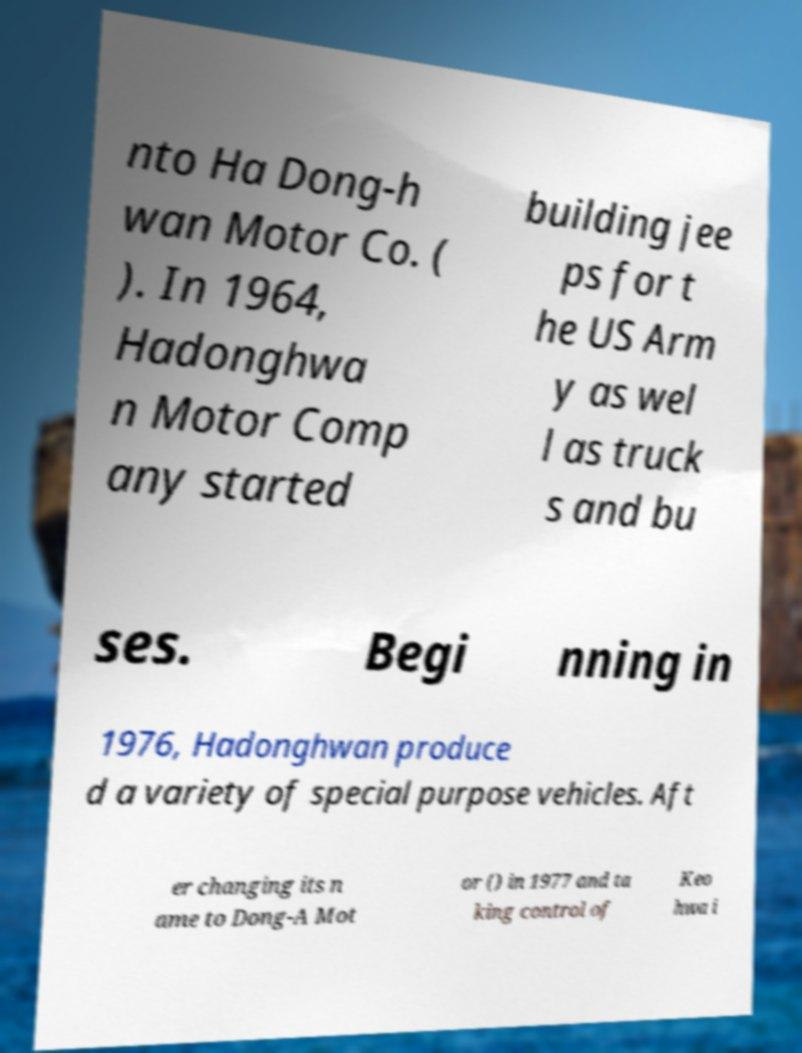Could you assist in decoding the text presented in this image and type it out clearly? nto Ha Dong-h wan Motor Co. ( ). In 1964, Hadonghwa n Motor Comp any started building jee ps for t he US Arm y as wel l as truck s and bu ses. Begi nning in 1976, Hadonghwan produce d a variety of special purpose vehicles. Aft er changing its n ame to Dong-A Mot or () in 1977 and ta king control of Keo hwa i 